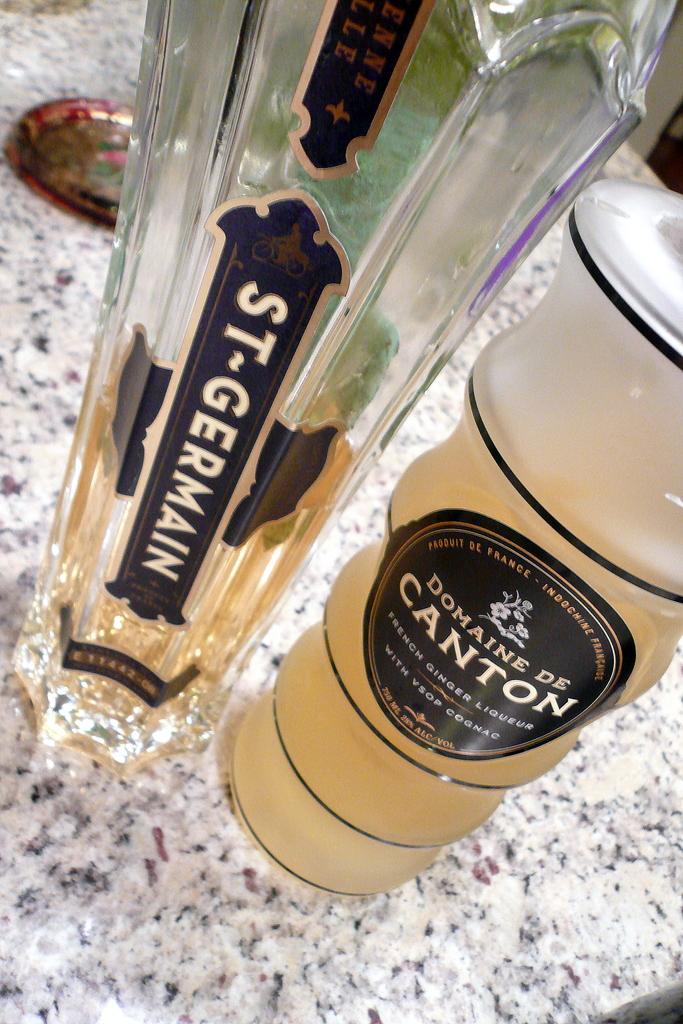What is the brand of the bottle on the left?
Provide a succinct answer. St germain . What brand is the bottle on the right?
Keep it short and to the point. Domaine de canton. 